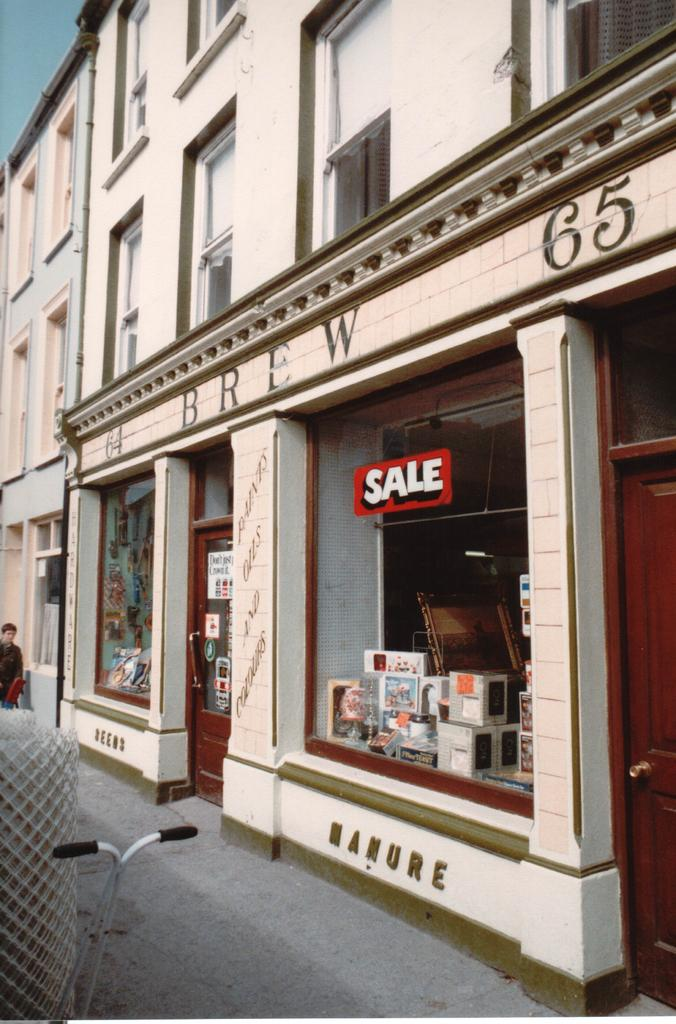What type of structure is present in the image? There is a building in the image. What type of establishment is located within the building? There is a store in the image. Can you describe the person in the image? The person is in the image and is on a path. What can be seen in the background of the image? There is a sky visible in the background of the image. Can you tell me how many shoes the squirrel is wearing in the image? There is no squirrel present in the image, and therefore no shoes can be observed. What type of ant can be seen walking on the person's shoulder in the image? There is no ant present in the image; only the person, the building, and the store are visible. 